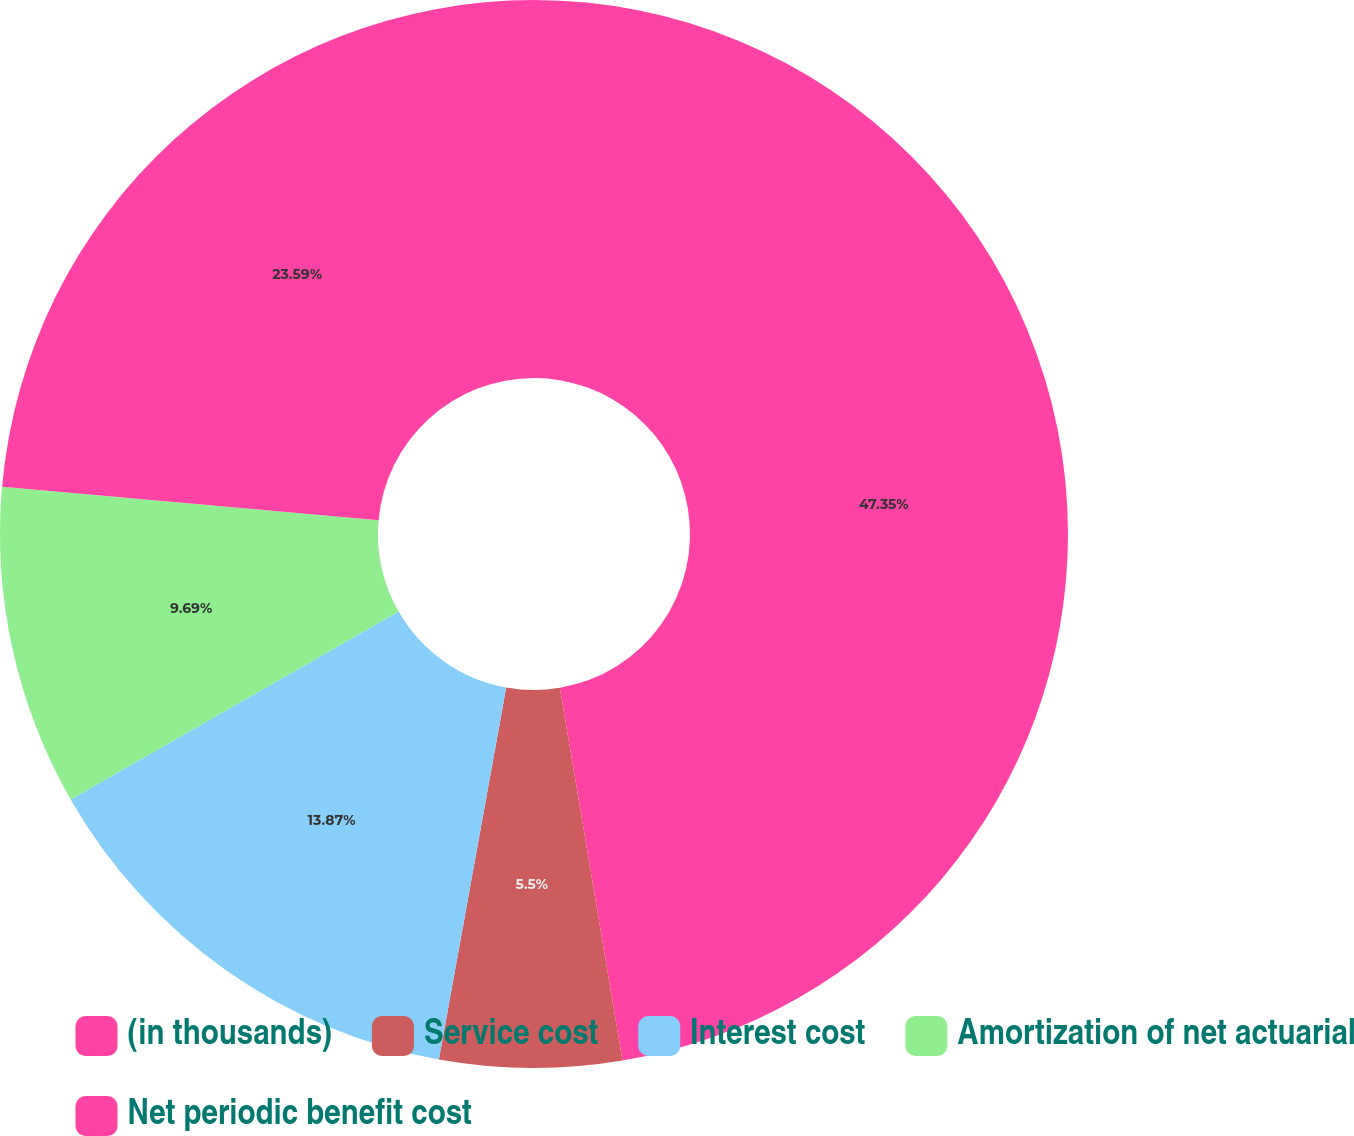<chart> <loc_0><loc_0><loc_500><loc_500><pie_chart><fcel>(in thousands)<fcel>Service cost<fcel>Interest cost<fcel>Amortization of net actuarial<fcel>Net periodic benefit cost<nl><fcel>47.35%<fcel>5.5%<fcel>13.87%<fcel>9.69%<fcel>23.59%<nl></chart> 